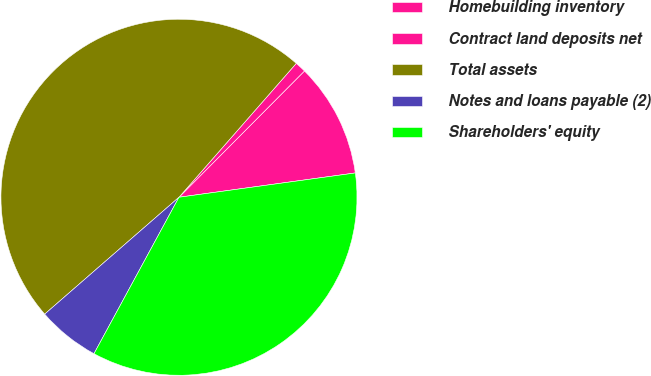<chart> <loc_0><loc_0><loc_500><loc_500><pie_chart><fcel>Homebuilding inventory<fcel>Contract land deposits net<fcel>Total assets<fcel>Notes and loans payable (2)<fcel>Shareholders' equity<nl><fcel>10.37%<fcel>1.0%<fcel>47.85%<fcel>5.68%<fcel>35.1%<nl></chart> 